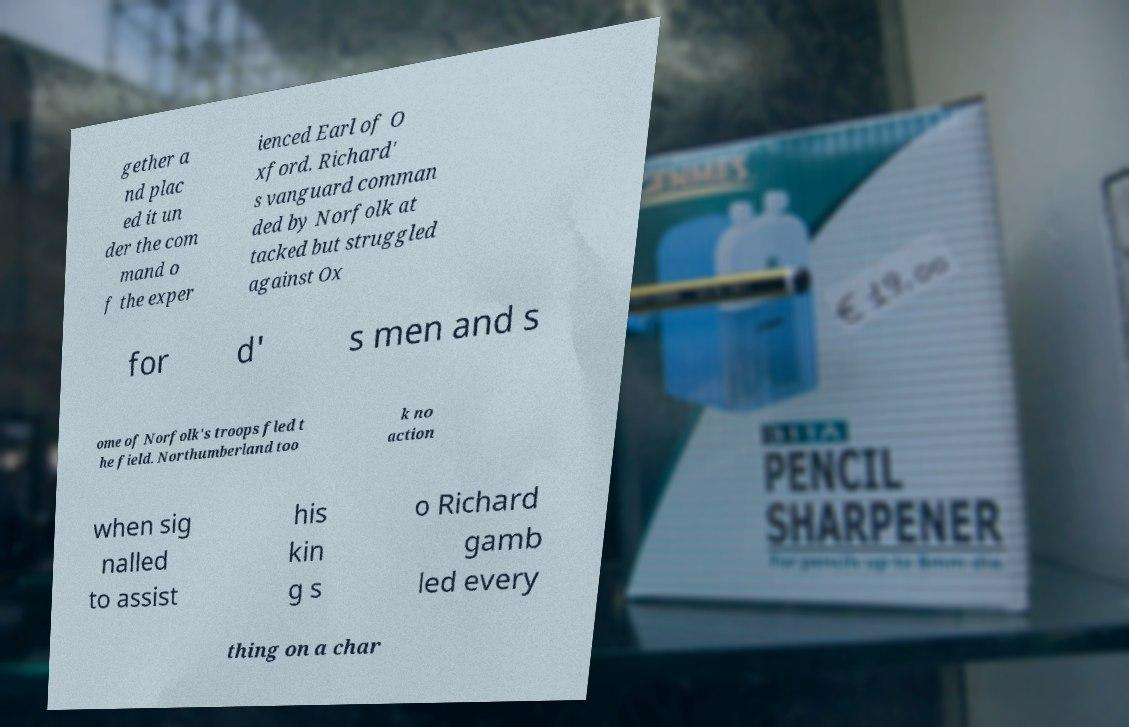Could you extract and type out the text from this image? gether a nd plac ed it un der the com mand o f the exper ienced Earl of O xford. Richard' s vanguard comman ded by Norfolk at tacked but struggled against Ox for d' s men and s ome of Norfolk's troops fled t he field. Northumberland too k no action when sig nalled to assist his kin g s o Richard gamb led every thing on a char 